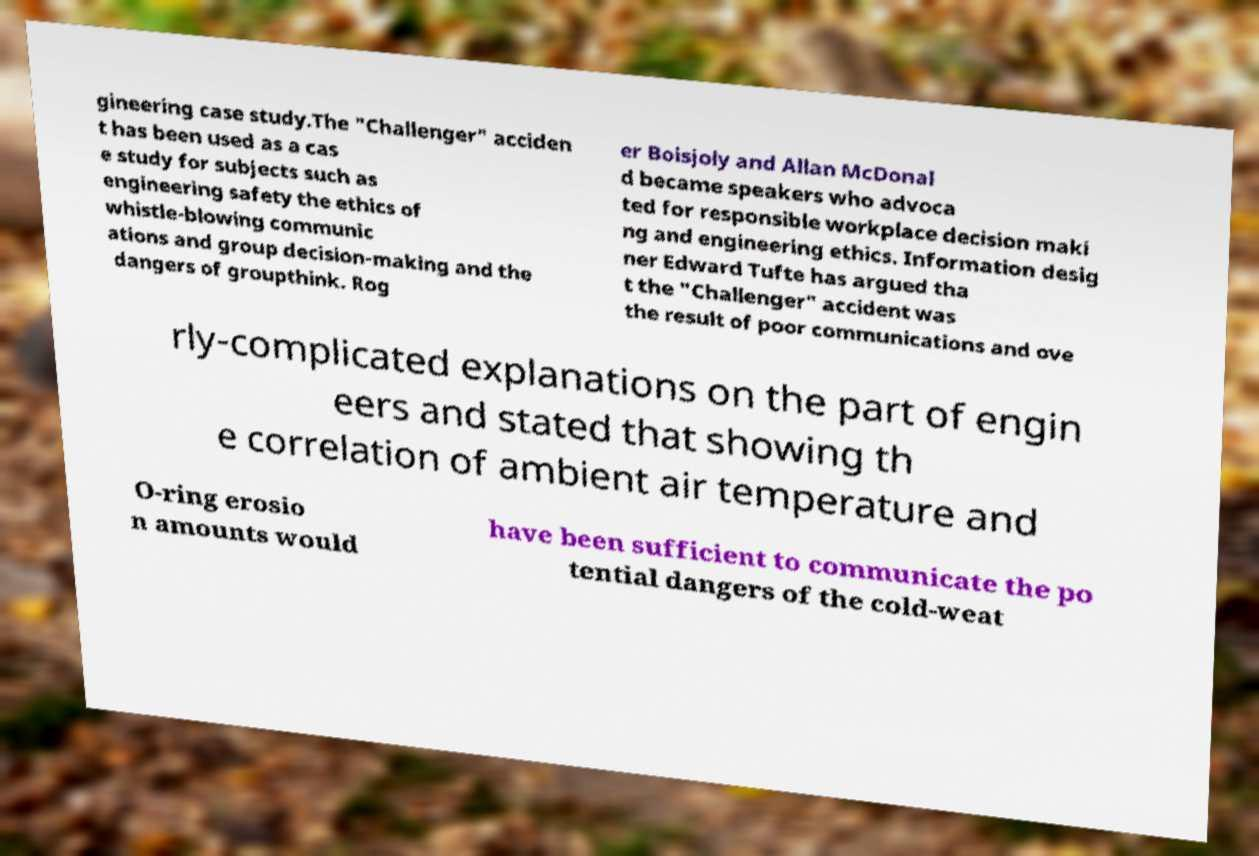Could you assist in decoding the text presented in this image and type it out clearly? gineering case study.The "Challenger" acciden t has been used as a cas e study for subjects such as engineering safety the ethics of whistle-blowing communic ations and group decision-making and the dangers of groupthink. Rog er Boisjoly and Allan McDonal d became speakers who advoca ted for responsible workplace decision maki ng and engineering ethics. Information desig ner Edward Tufte has argued tha t the "Challenger" accident was the result of poor communications and ove rly-complicated explanations on the part of engin eers and stated that showing th e correlation of ambient air temperature and O-ring erosio n amounts would have been sufficient to communicate the po tential dangers of the cold-weat 